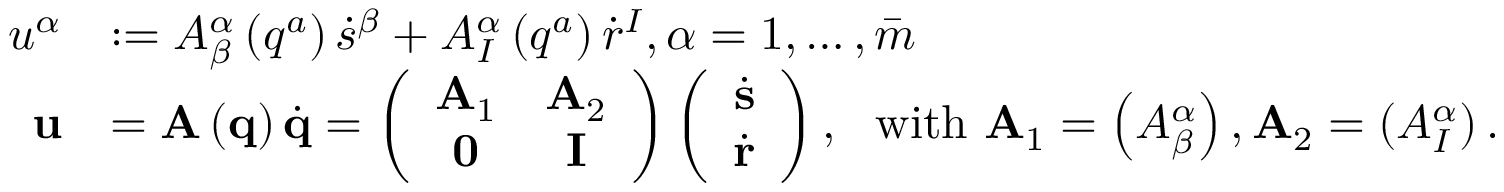Convert formula to latex. <formula><loc_0><loc_0><loc_500><loc_500>\begin{array} { r l } { u ^ { \alpha } } & { \colon = A _ { \beta } ^ { \alpha } \left ( q ^ { a } \right ) \dot { s } ^ { \beta } + A _ { I } ^ { \alpha } \left ( q ^ { a } \right ) \dot { r } ^ { I } , \alpha = 1 , \dots , \bar { m } } \\ { u } & { = A \left ( q \right ) \dot { q } = \left ( \begin{array} { c c } { A _ { 1 } } & { A _ { 2 } } \\ { 0 } & { I } \end{array} \right ) \left ( \begin{array} { c } { \dot { s } } \\ { \dot { r } } \end{array} \right ) , \ \ w i t h \ A _ { 1 } = \left ( A _ { \beta } ^ { \alpha } \right ) , A _ { 2 } = \left ( A _ { I } ^ { \alpha } \right ) . } \end{array}</formula> 